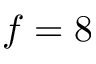<formula> <loc_0><loc_0><loc_500><loc_500>f = 8</formula> 